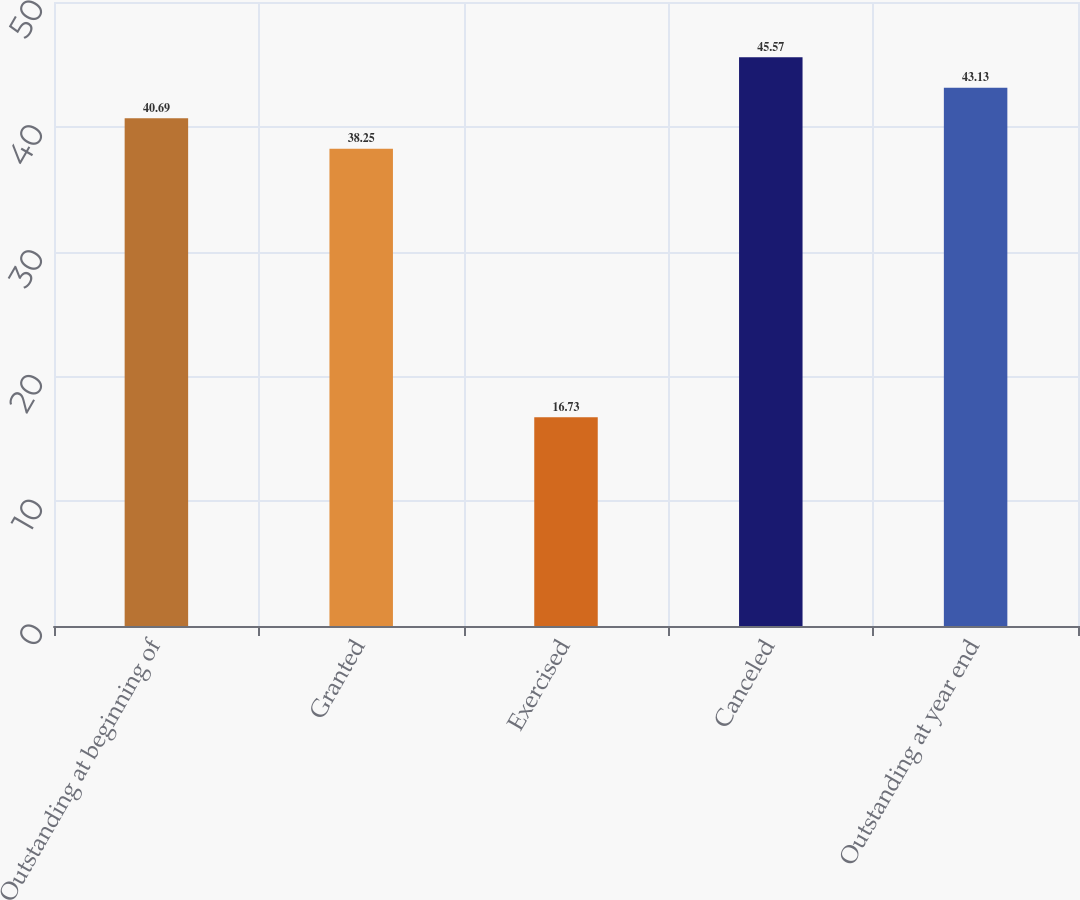Convert chart. <chart><loc_0><loc_0><loc_500><loc_500><bar_chart><fcel>Outstanding at beginning of<fcel>Granted<fcel>Exercised<fcel>Canceled<fcel>Outstanding at year end<nl><fcel>40.69<fcel>38.25<fcel>16.73<fcel>45.57<fcel>43.13<nl></chart> 